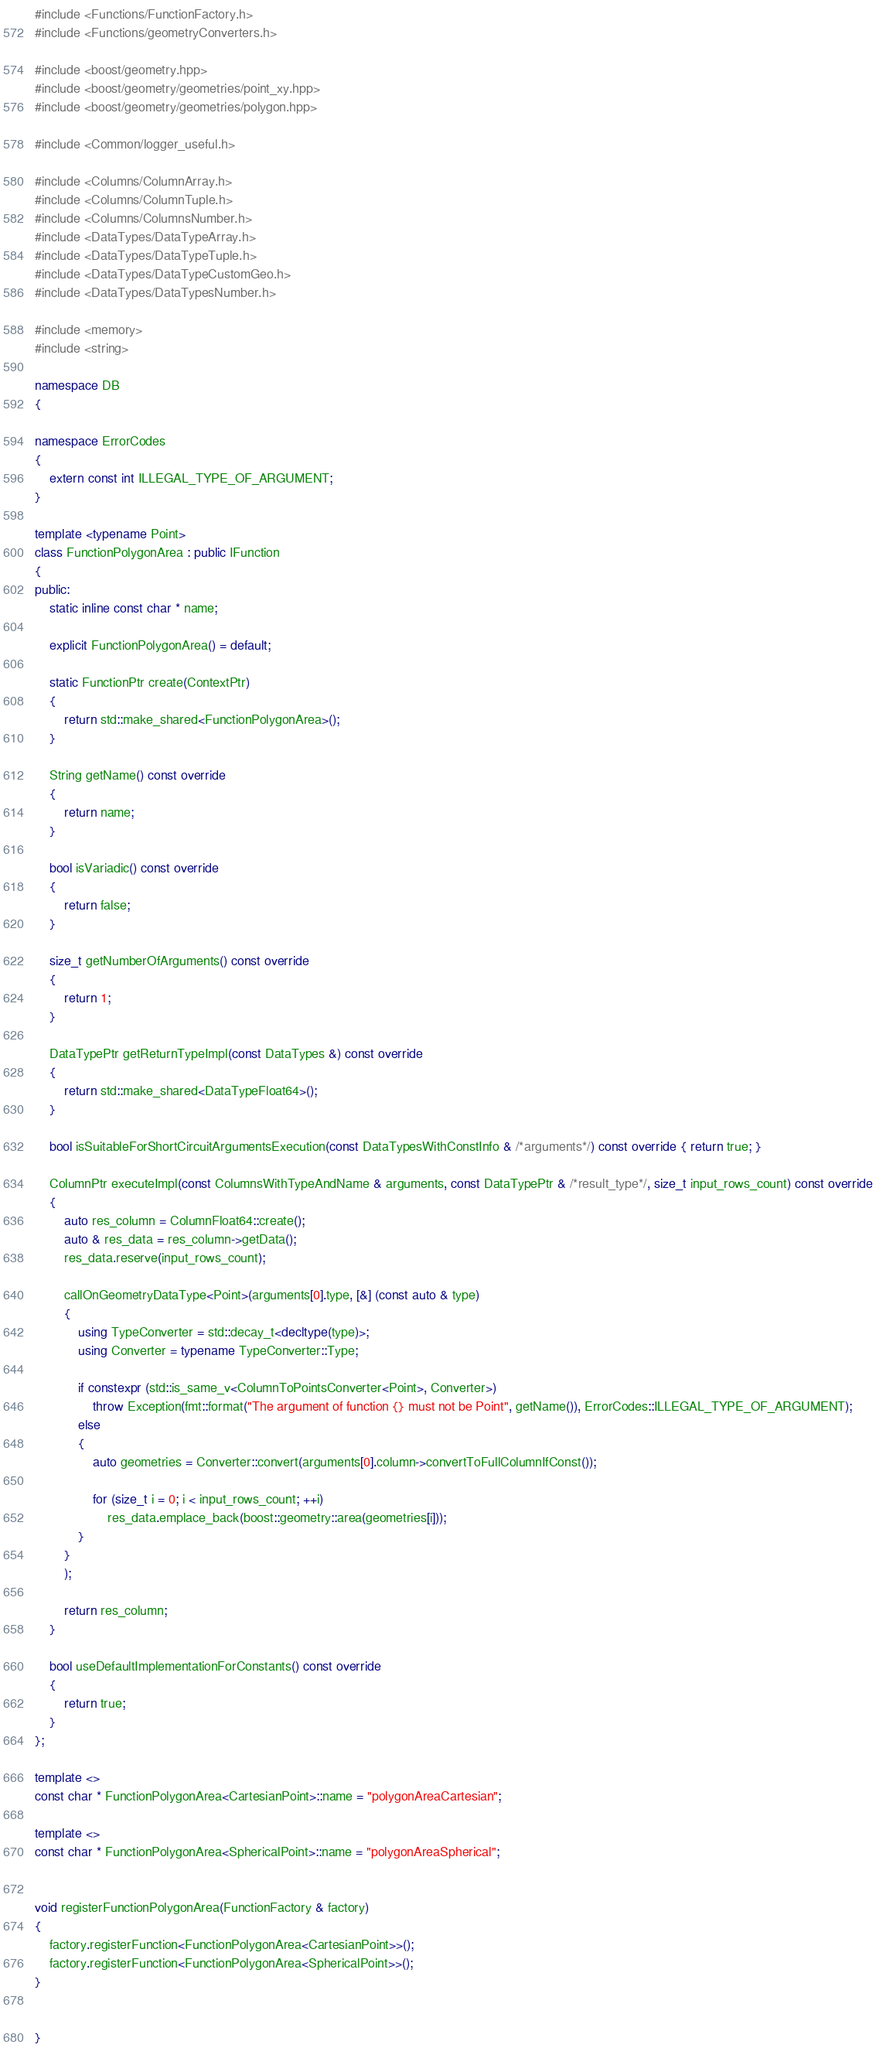Convert code to text. <code><loc_0><loc_0><loc_500><loc_500><_C++_>#include <Functions/FunctionFactory.h>
#include <Functions/geometryConverters.h>

#include <boost/geometry.hpp>
#include <boost/geometry/geometries/point_xy.hpp>
#include <boost/geometry/geometries/polygon.hpp>

#include <Common/logger_useful.h>

#include <Columns/ColumnArray.h>
#include <Columns/ColumnTuple.h>
#include <Columns/ColumnsNumber.h>
#include <DataTypes/DataTypeArray.h>
#include <DataTypes/DataTypeTuple.h>
#include <DataTypes/DataTypeCustomGeo.h>
#include <DataTypes/DataTypesNumber.h>

#include <memory>
#include <string>

namespace DB
{

namespace ErrorCodes
{
    extern const int ILLEGAL_TYPE_OF_ARGUMENT;
}

template <typename Point>
class FunctionPolygonArea : public IFunction
{
public:
    static inline const char * name;

    explicit FunctionPolygonArea() = default;

    static FunctionPtr create(ContextPtr)
    {
        return std::make_shared<FunctionPolygonArea>();
    }

    String getName() const override
    {
        return name;
    }

    bool isVariadic() const override
    {
        return false;
    }

    size_t getNumberOfArguments() const override
    {
        return 1;
    }

    DataTypePtr getReturnTypeImpl(const DataTypes &) const override
    {
        return std::make_shared<DataTypeFloat64>();
    }

    bool isSuitableForShortCircuitArgumentsExecution(const DataTypesWithConstInfo & /*arguments*/) const override { return true; }

    ColumnPtr executeImpl(const ColumnsWithTypeAndName & arguments, const DataTypePtr & /*result_type*/, size_t input_rows_count) const override
    {
        auto res_column = ColumnFloat64::create();
        auto & res_data = res_column->getData();
        res_data.reserve(input_rows_count);

        callOnGeometryDataType<Point>(arguments[0].type, [&] (const auto & type)
        {
            using TypeConverter = std::decay_t<decltype(type)>;
            using Converter = typename TypeConverter::Type;

            if constexpr (std::is_same_v<ColumnToPointsConverter<Point>, Converter>)
                throw Exception(fmt::format("The argument of function {} must not be Point", getName()), ErrorCodes::ILLEGAL_TYPE_OF_ARGUMENT);
            else
            {
                auto geometries = Converter::convert(arguments[0].column->convertToFullColumnIfConst());

                for (size_t i = 0; i < input_rows_count; ++i)
                    res_data.emplace_back(boost::geometry::area(geometries[i]));
            }
        }
        );

        return res_column;
    }

    bool useDefaultImplementationForConstants() const override
    {
        return true;
    }
};

template <>
const char * FunctionPolygonArea<CartesianPoint>::name = "polygonAreaCartesian";

template <>
const char * FunctionPolygonArea<SphericalPoint>::name = "polygonAreaSpherical";


void registerFunctionPolygonArea(FunctionFactory & factory)
{
    factory.registerFunction<FunctionPolygonArea<CartesianPoint>>();
    factory.registerFunction<FunctionPolygonArea<SphericalPoint>>();
}


}
</code> 